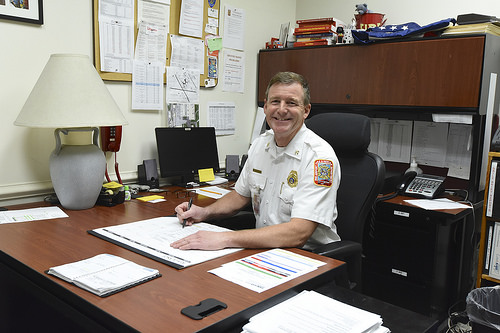<image>
Is there a fireman behind the desk? Yes. From this viewpoint, the fireman is positioned behind the desk, with the desk partially or fully occluding the fireman. 